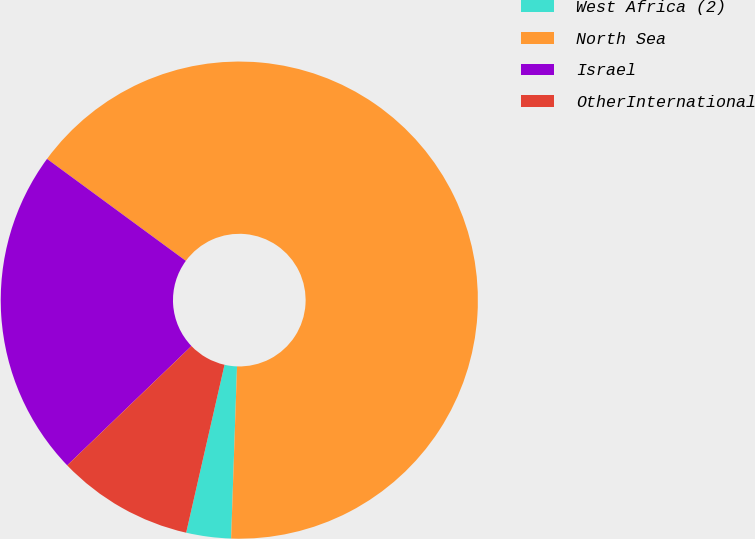Convert chart to OTSL. <chart><loc_0><loc_0><loc_500><loc_500><pie_chart><fcel>West Africa (2)<fcel>North Sea<fcel>Israel<fcel>OtherInternational<nl><fcel>3.03%<fcel>65.47%<fcel>22.26%<fcel>9.25%<nl></chart> 